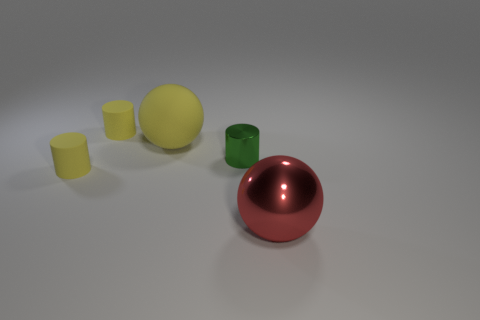Add 1 blue matte objects. How many objects exist? 6 Subtract all spheres. How many objects are left? 3 Add 1 green cubes. How many green cubes exist? 1 Subtract 1 green cylinders. How many objects are left? 4 Subtract all big red metal objects. Subtract all metallic objects. How many objects are left? 2 Add 4 small shiny cylinders. How many small shiny cylinders are left? 5 